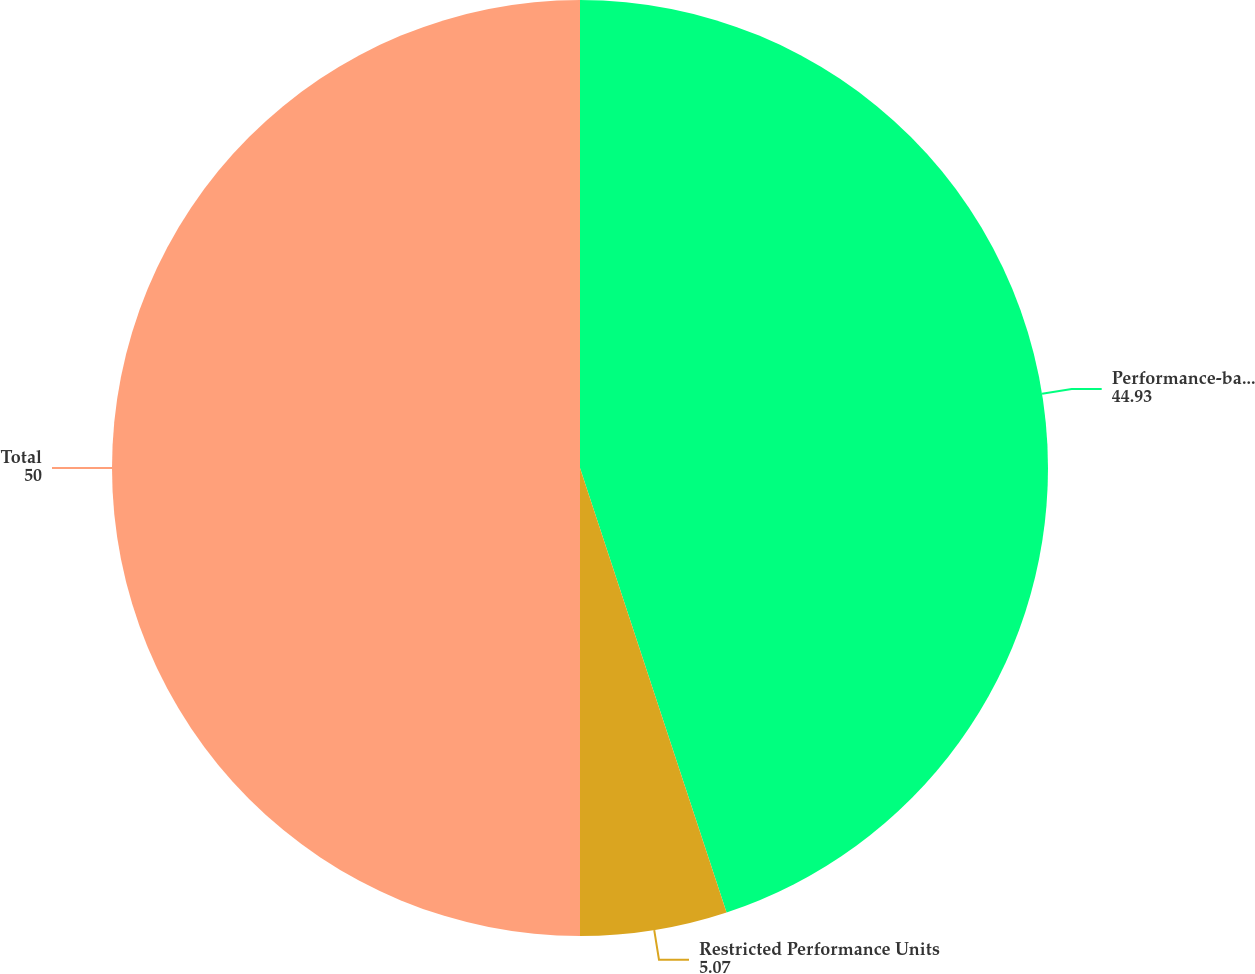<chart> <loc_0><loc_0><loc_500><loc_500><pie_chart><fcel>Performance-based options<fcel>Restricted Performance Units<fcel>Total<nl><fcel>44.93%<fcel>5.07%<fcel>50.0%<nl></chart> 